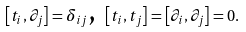<formula> <loc_0><loc_0><loc_500><loc_500>\left [ t _ { i } , \partial _ { j } \right ] = \delta _ { i j } \text {, } \left [ t _ { i } , t _ { j } \right ] = \left [ \partial _ { i } , \partial _ { j } \right ] = 0 .</formula> 